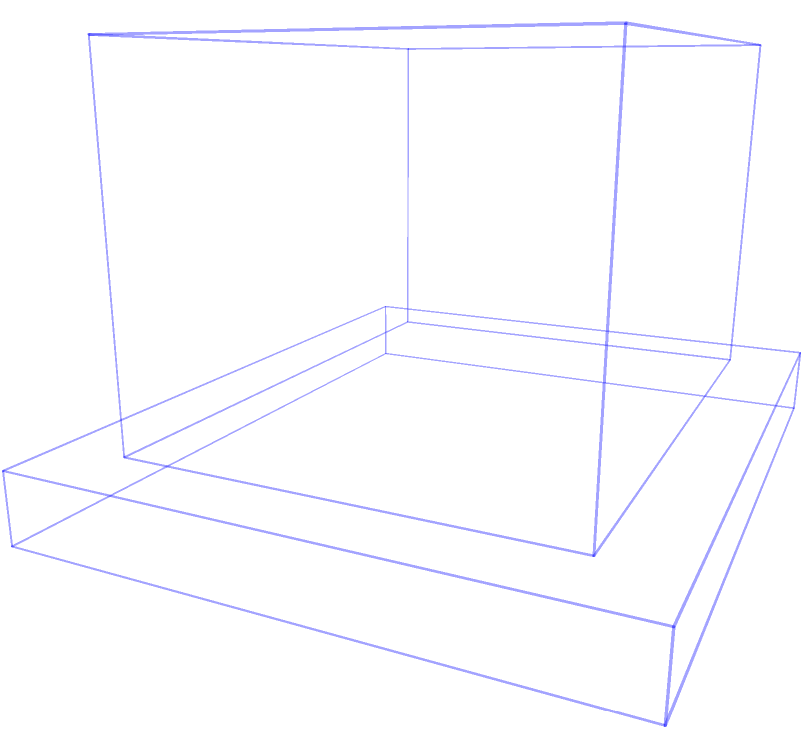As an experienced builder, you're tasked with calculating the total volume of a complex architectural structure. The structure consists of a rectangular base (10m x 8m x 1m), a main rectangular body (8m x 6m x 5m) sitting on top of the base, and a cylindrical tower (radius 2m, height 4m) on top of the main body. What is the total volume of this structure in cubic meters? To calculate the total volume, we need to sum the volumes of each component:

1. Volume of the base:
   $V_{base} = 10m \times 8m \times 1m = 80m^3$

2. Volume of the main rectangular body:
   $V_{main} = 8m \times 6m \times 5m = 240m^3$

3. Volume of the cylindrical tower:
   $V_{tower} = \pi r^2 h = \pi \times (2m)^2 \times 4m = 16\pi m^3$

Total volume:
$$V_{total} = V_{base} + V_{main} + V_{tower}$$
$$V_{total} = 80m^3 + 240m^3 + 16\pi m^3$$
$$V_{total} = 320m^3 + 16\pi m^3$$
$$V_{total} = 320 + 16\pi \approx 370.27m^3$$
Answer: $370.27m^3$ 